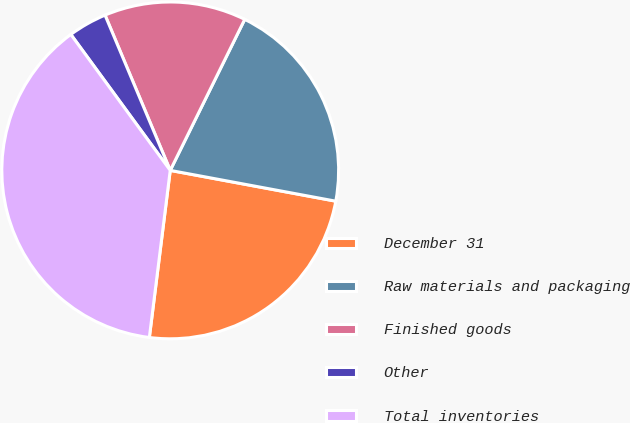Convert chart to OTSL. <chart><loc_0><loc_0><loc_500><loc_500><pie_chart><fcel>December 31<fcel>Raw materials and packaging<fcel>Finished goods<fcel>Other<fcel>Total inventories<nl><fcel>24.05%<fcel>20.63%<fcel>13.62%<fcel>3.72%<fcel>37.97%<nl></chart> 